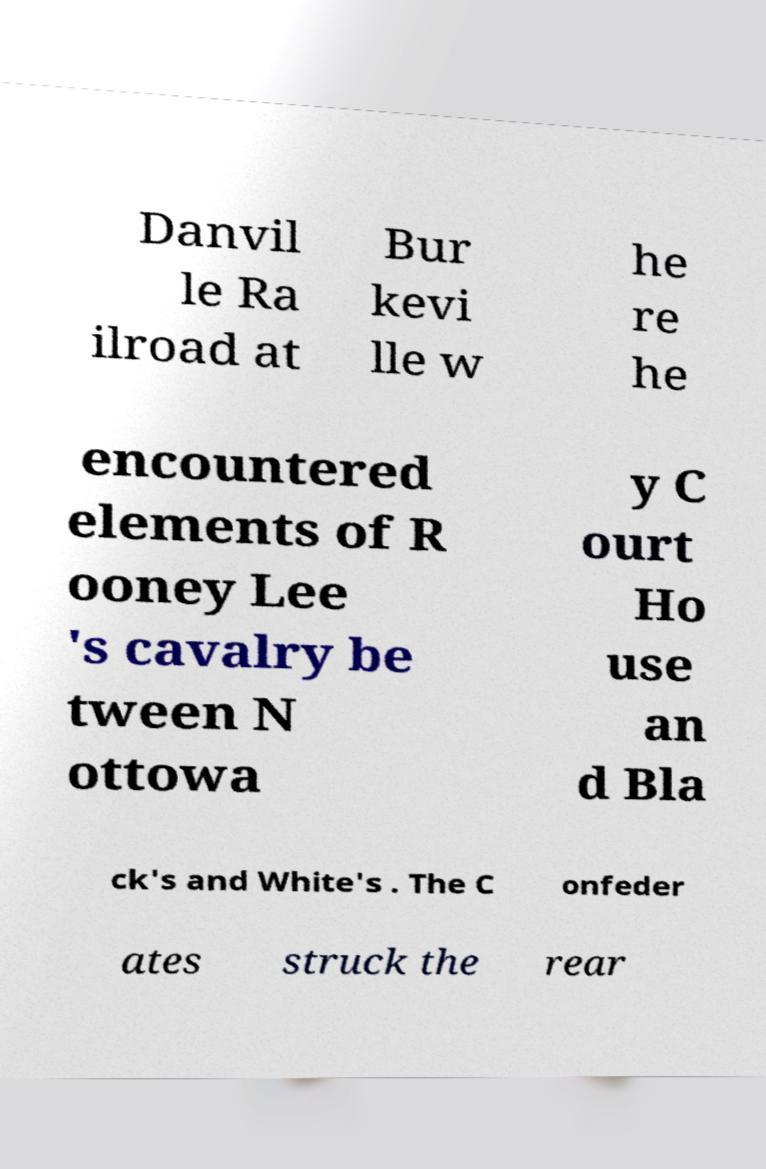Could you assist in decoding the text presented in this image and type it out clearly? Danvil le Ra ilroad at Bur kevi lle w he re he encountered elements of R ooney Lee 's cavalry be tween N ottowa y C ourt Ho use an d Bla ck's and White's . The C onfeder ates struck the rear 